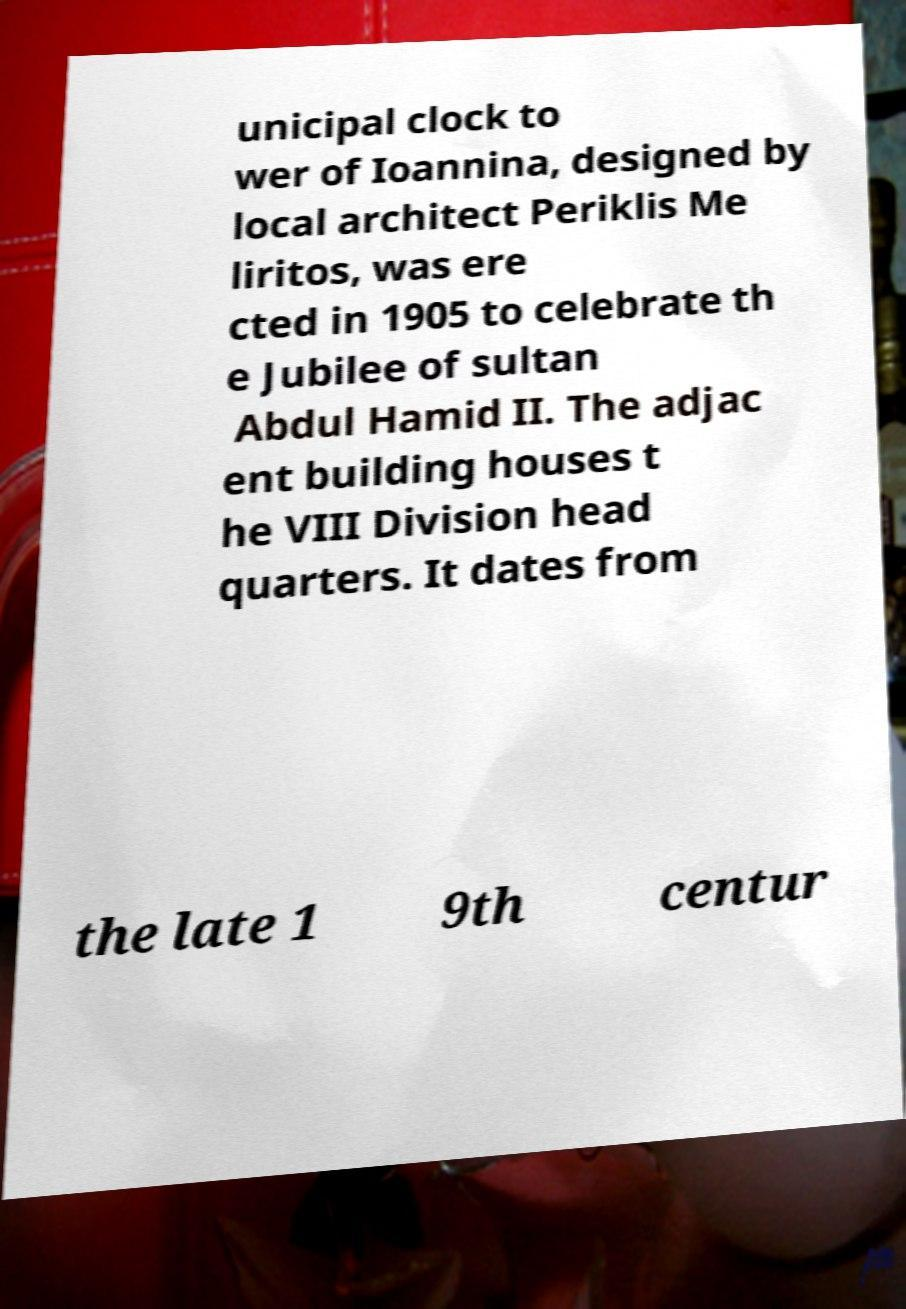Can you read and provide the text displayed in the image?This photo seems to have some interesting text. Can you extract and type it out for me? unicipal clock to wer of Ioannina, designed by local architect Periklis Me liritos, was ere cted in 1905 to celebrate th e Jubilee of sultan Abdul Hamid II. The adjac ent building houses t he VIII Division head quarters. It dates from the late 1 9th centur 